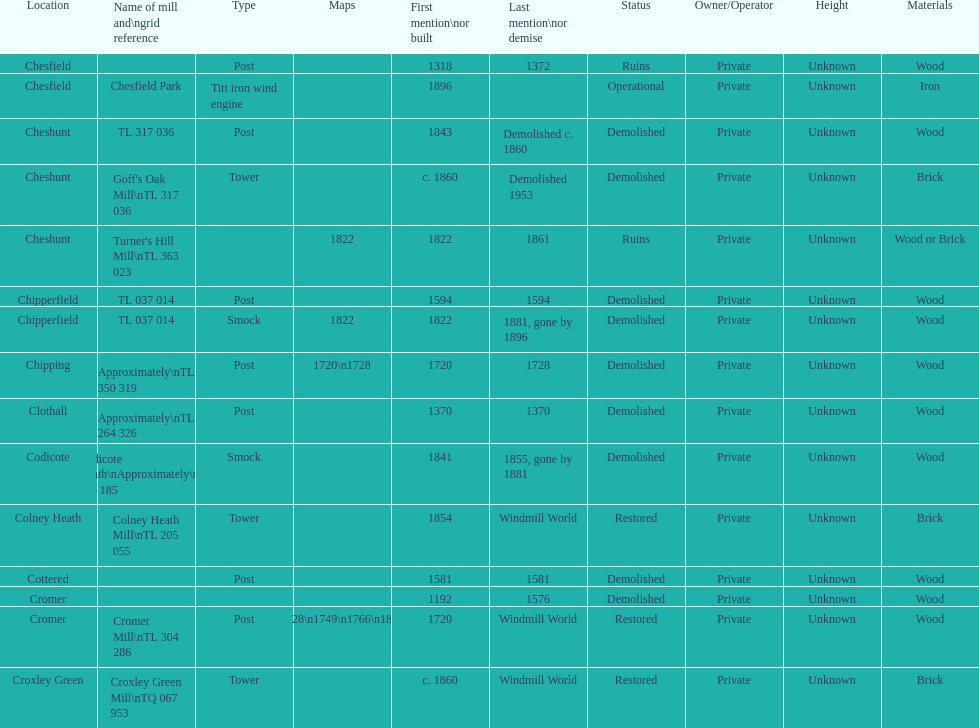How man "c" windmills have there been? 15. 